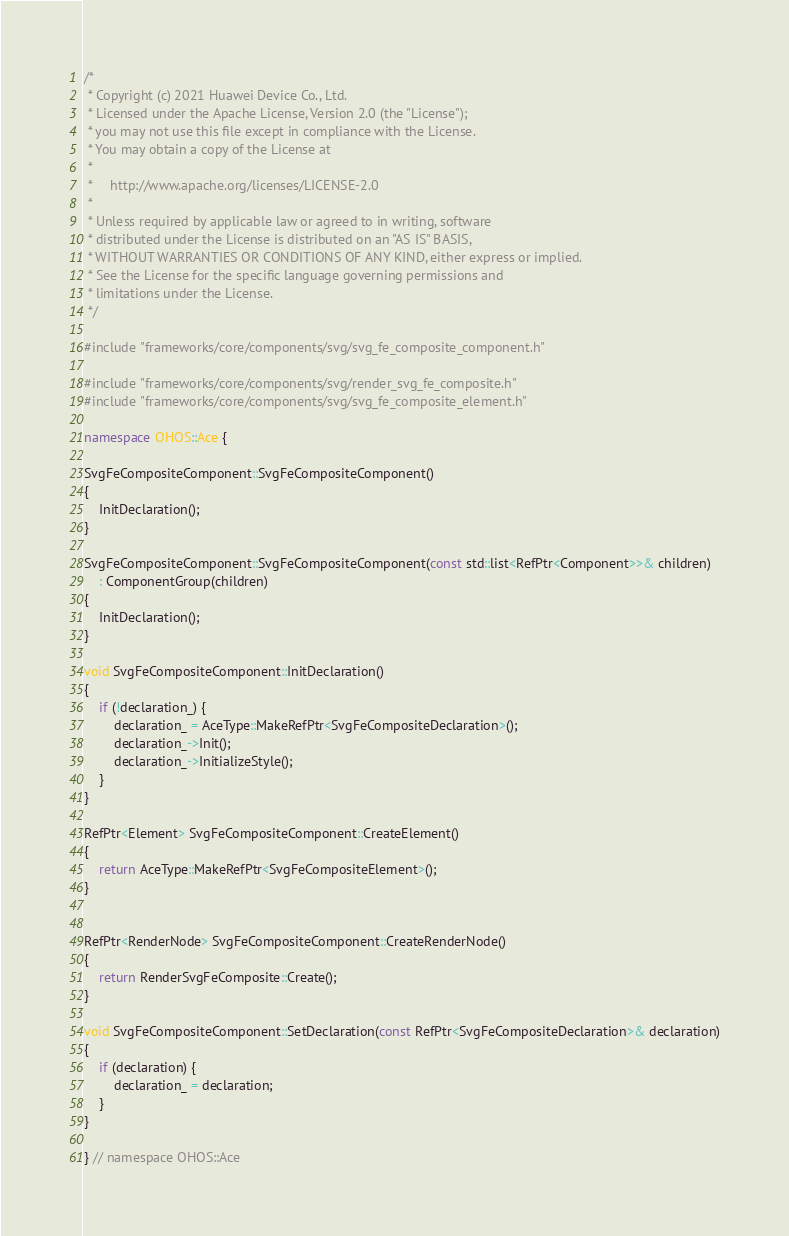Convert code to text. <code><loc_0><loc_0><loc_500><loc_500><_C++_>/*
 * Copyright (c) 2021 Huawei Device Co., Ltd.
 * Licensed under the Apache License, Version 2.0 (the "License");
 * you may not use this file except in compliance with the License.
 * You may obtain a copy of the License at
 *
 *     http://www.apache.org/licenses/LICENSE-2.0
 *
 * Unless required by applicable law or agreed to in writing, software
 * distributed under the License is distributed on an "AS IS" BASIS,
 * WITHOUT WARRANTIES OR CONDITIONS OF ANY KIND, either express or implied.
 * See the License for the specific language governing permissions and
 * limitations under the License.
 */

#include "frameworks/core/components/svg/svg_fe_composite_component.h"

#include "frameworks/core/components/svg/render_svg_fe_composite.h"
#include "frameworks/core/components/svg/svg_fe_composite_element.h"

namespace OHOS::Ace {

SvgFeCompositeComponent::SvgFeCompositeComponent()
{
    InitDeclaration();
}

SvgFeCompositeComponent::SvgFeCompositeComponent(const std::list<RefPtr<Component>>& children)
    : ComponentGroup(children)
{
    InitDeclaration();
}

void SvgFeCompositeComponent::InitDeclaration()
{
    if (!declaration_) {
        declaration_ = AceType::MakeRefPtr<SvgFeCompositeDeclaration>();
        declaration_->Init();
        declaration_->InitializeStyle();
    }
}

RefPtr<Element> SvgFeCompositeComponent::CreateElement()
{
    return AceType::MakeRefPtr<SvgFeCompositeElement>();
}


RefPtr<RenderNode> SvgFeCompositeComponent::CreateRenderNode()
{
    return RenderSvgFeComposite::Create();
}

void SvgFeCompositeComponent::SetDeclaration(const RefPtr<SvgFeCompositeDeclaration>& declaration)
{
    if (declaration) {
        declaration_ = declaration;
    }
}

} // namespace OHOS::Ace
</code> 